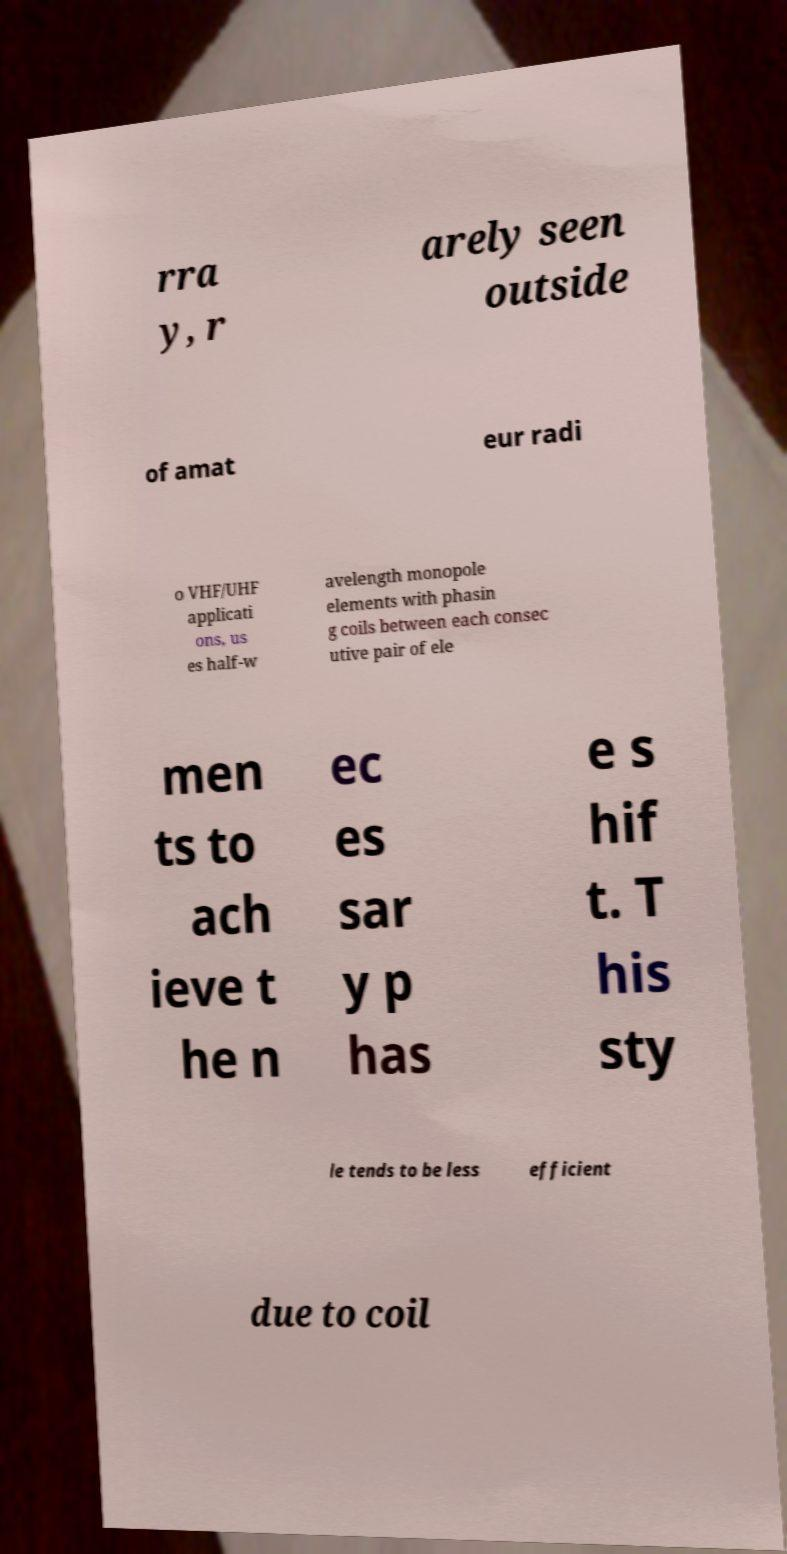Can you read and provide the text displayed in the image?This photo seems to have some interesting text. Can you extract and type it out for me? rra y, r arely seen outside of amat eur radi o VHF/UHF applicati ons, us es half-w avelength monopole elements with phasin g coils between each consec utive pair of ele men ts to ach ieve t he n ec es sar y p has e s hif t. T his sty le tends to be less efficient due to coil 